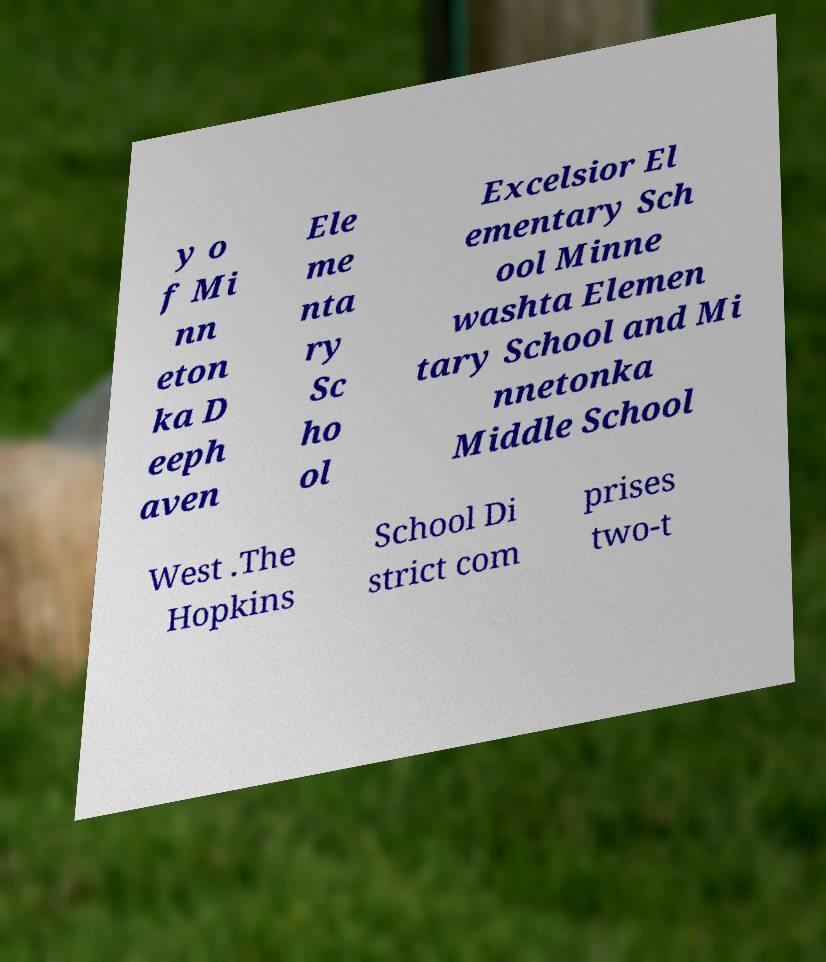Please read and relay the text visible in this image. What does it say? y o f Mi nn eton ka D eeph aven Ele me nta ry Sc ho ol Excelsior El ementary Sch ool Minne washta Elemen tary School and Mi nnetonka Middle School West .The Hopkins School Di strict com prises two-t 